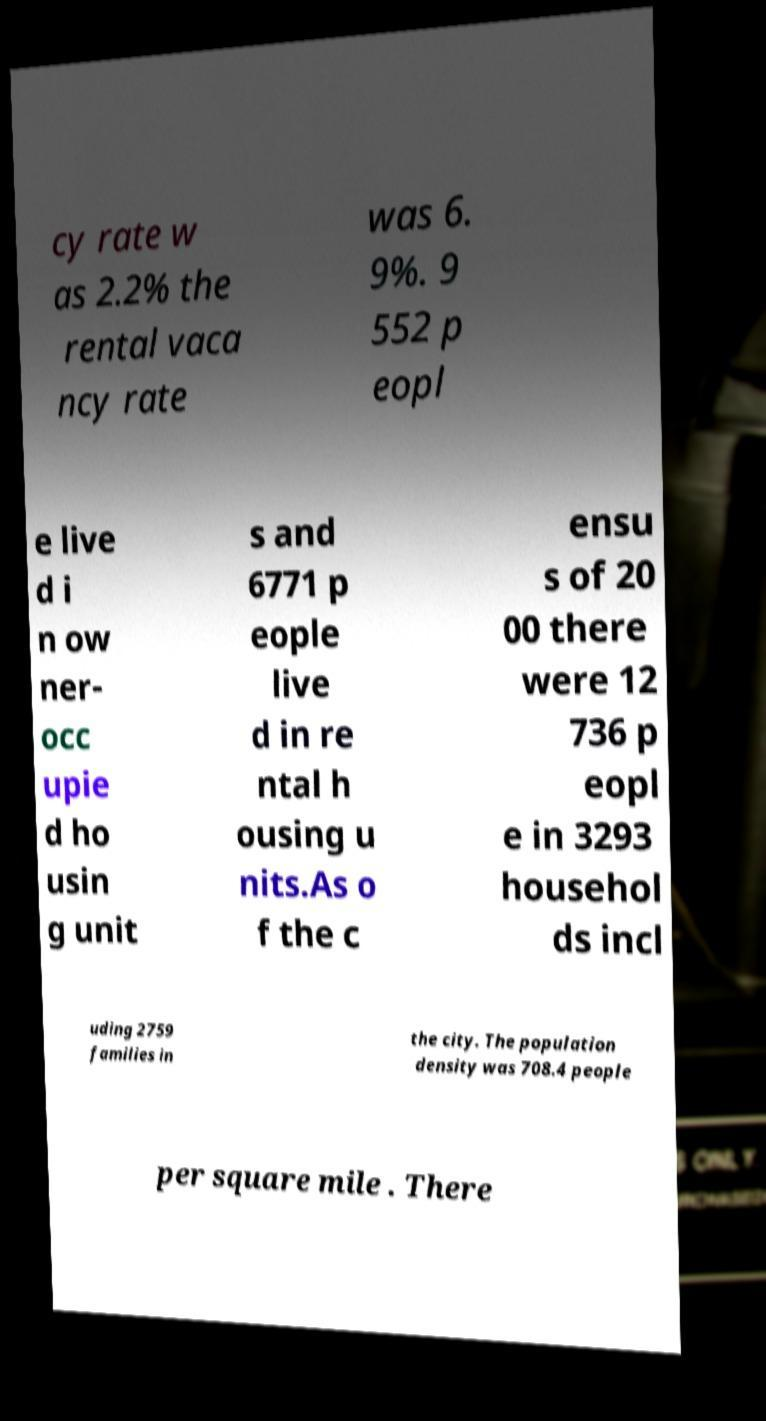There's text embedded in this image that I need extracted. Can you transcribe it verbatim? cy rate w as 2.2% the rental vaca ncy rate was 6. 9%. 9 552 p eopl e live d i n ow ner- occ upie d ho usin g unit s and 6771 p eople live d in re ntal h ousing u nits.As o f the c ensu s of 20 00 there were 12 736 p eopl e in 3293 househol ds incl uding 2759 families in the city. The population density was 708.4 people per square mile . There 